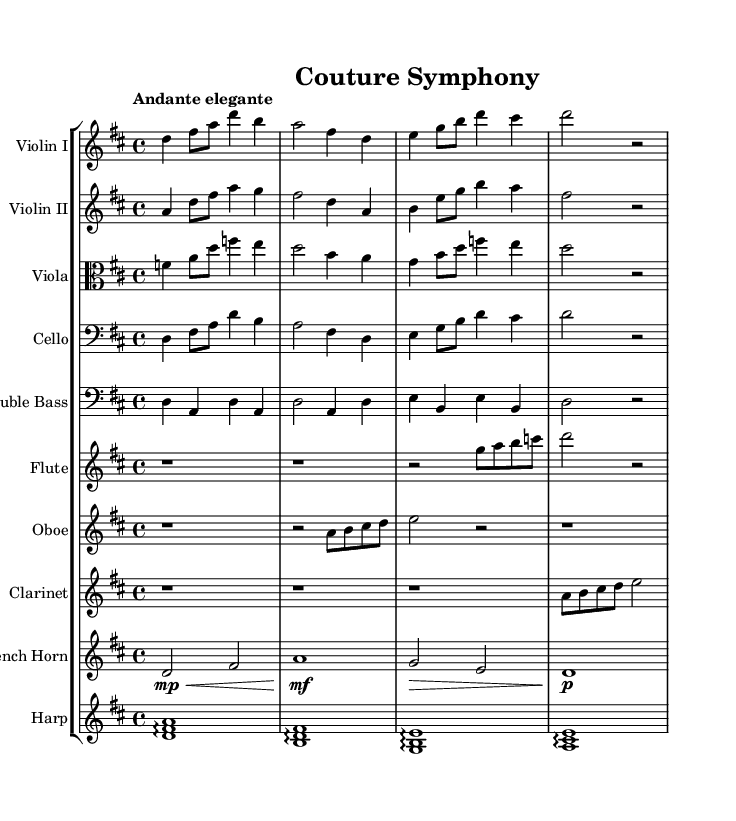What is the key signature of this music? The key signature of the piece is D major, which features two sharps (F# and C#). This can be identified in the key signature section at the beginning of the score.
Answer: D major What is the time signature of the piece? The time signature of the music is 4/4, which can be found at the beginning of the score. This indicates that there are four beats per measure and the quarter note gets one beat.
Answer: 4/4 What is the tempo marking for this symphony? The tempo marking is "Andante elegante." This is indicated at the start of the score and suggests a moderately slow pace, appropriate for a romantic orchestral piece.
Answer: Andante elegante How many measures are there in the violins' parts? The violin I and II parts each consist of four measures as shown in their respective staffs, counted clearly from the beginning to the end of their segments.
Answer: Four Which instrument plays the arpeggio in the piece? The harp is the instrument that primarily features the arpeggio, which can be recognized in its staff where the notes are played in succession rather than simultaneously.
Answer: Harp What is the dynamic marking for the french horn in measure two? The dynamic marking for the french horn in measure two is "mf," which indicates a moderately loud dynamic, as noted directly above the French horn staff.
Answer: mf What is the texture type of the piece based on the orchestration? The piece has a homophonic texture, characterized by a clear melody in the violins with accompanying harmony from the other instruments, which can be observed throughout the score.
Answer: Homophonic 